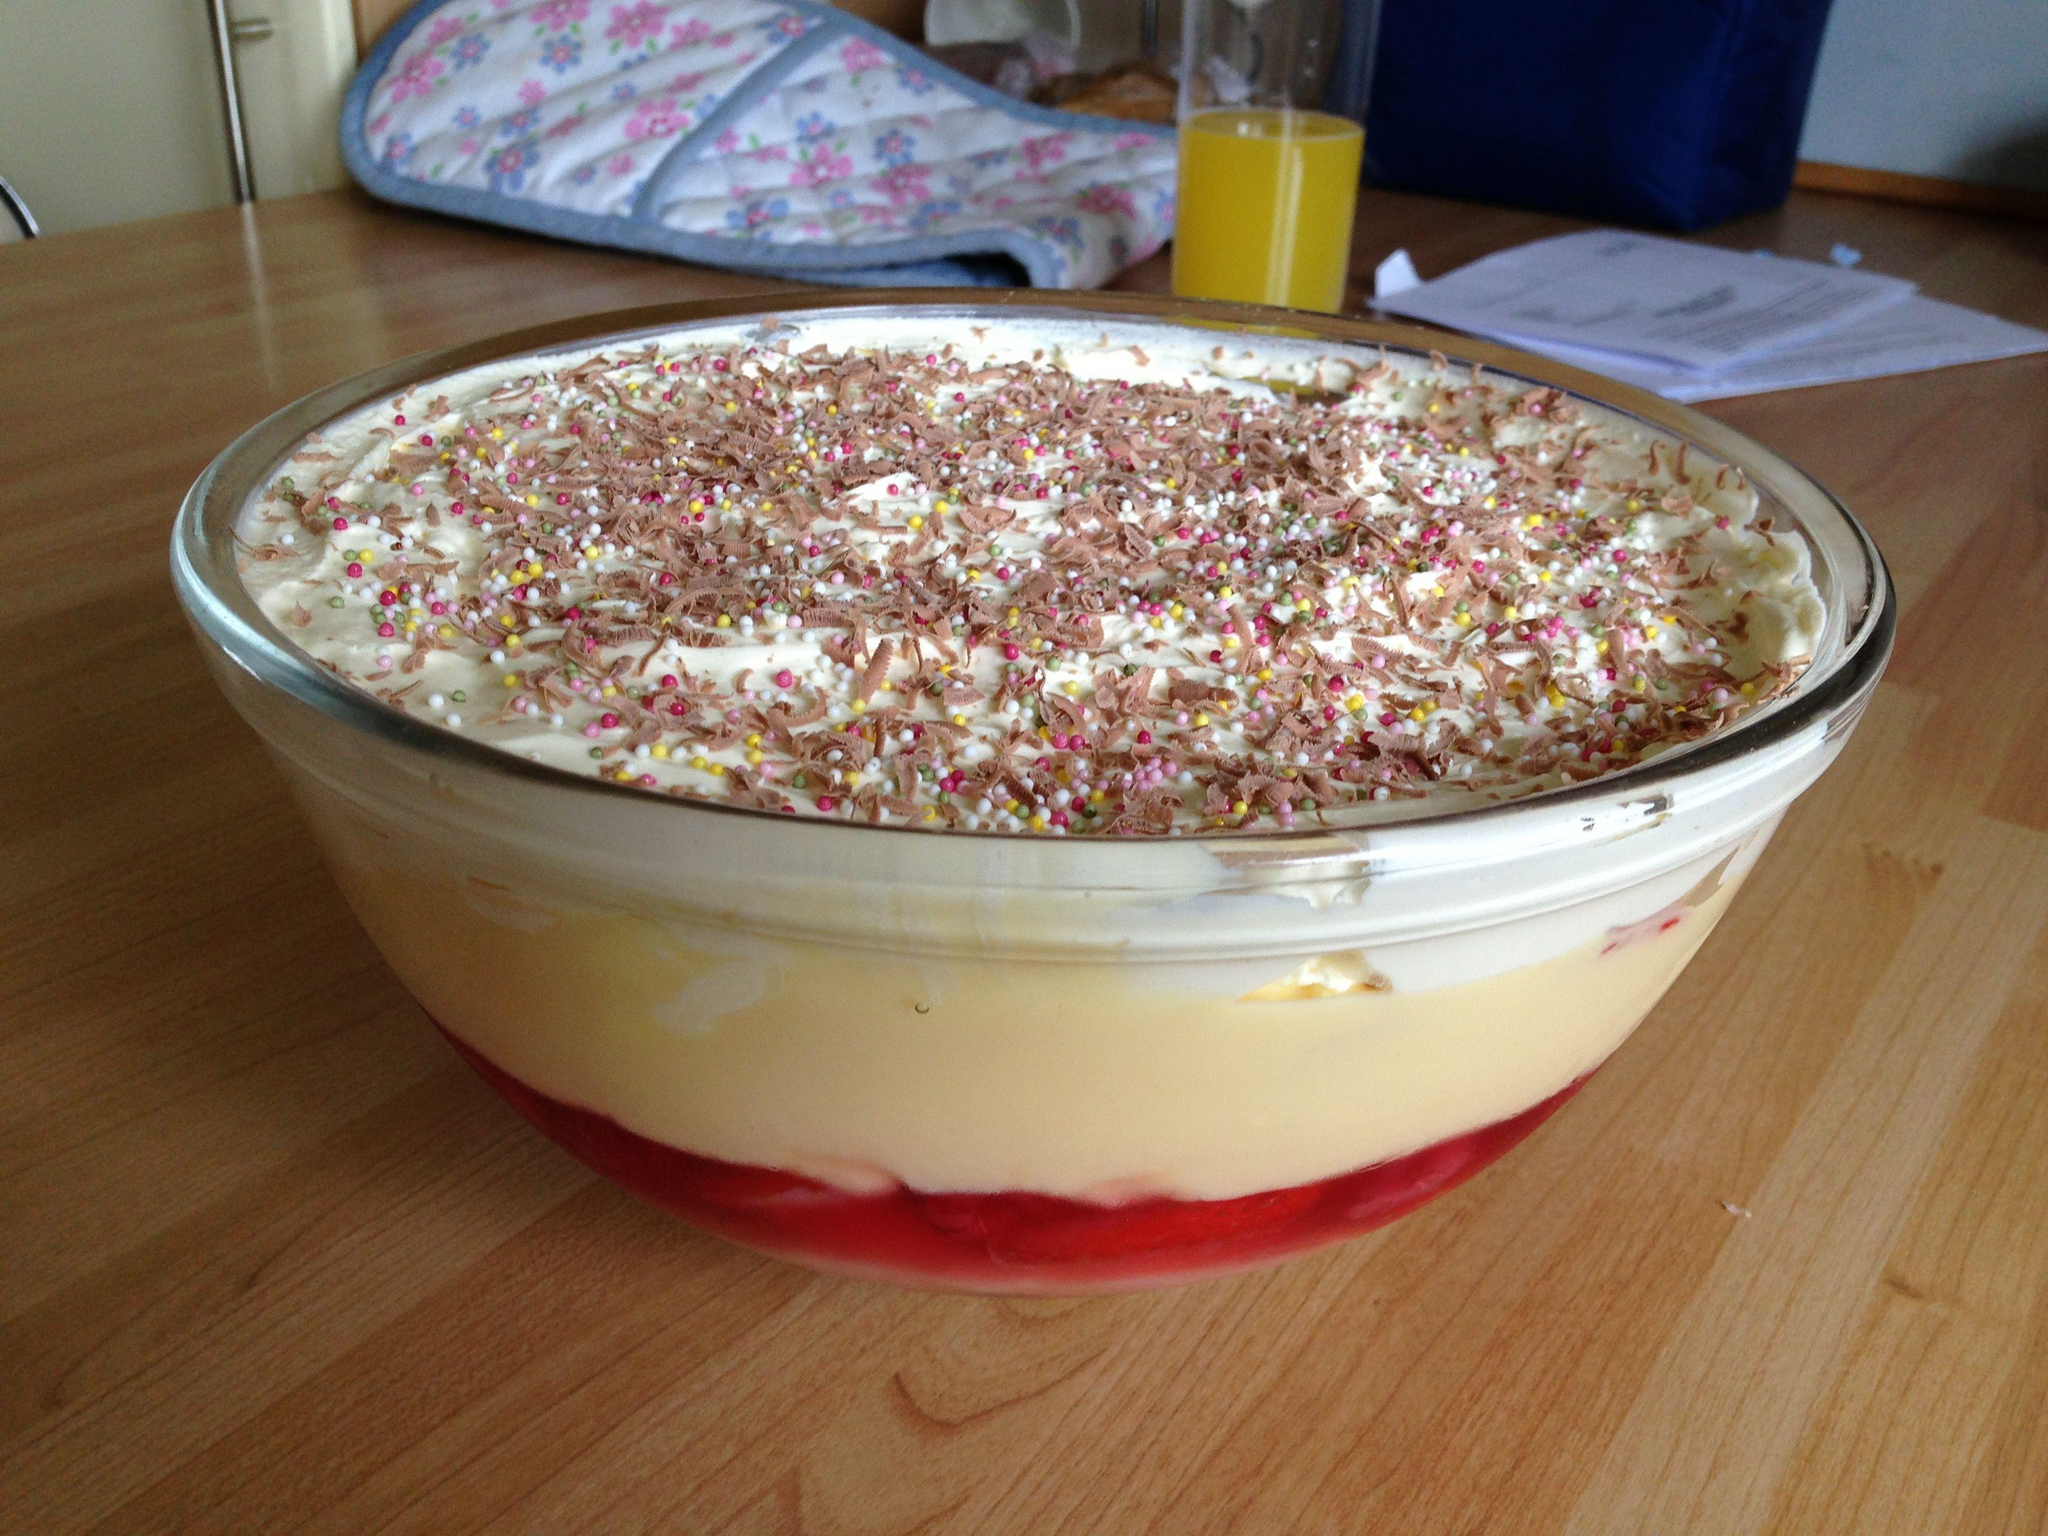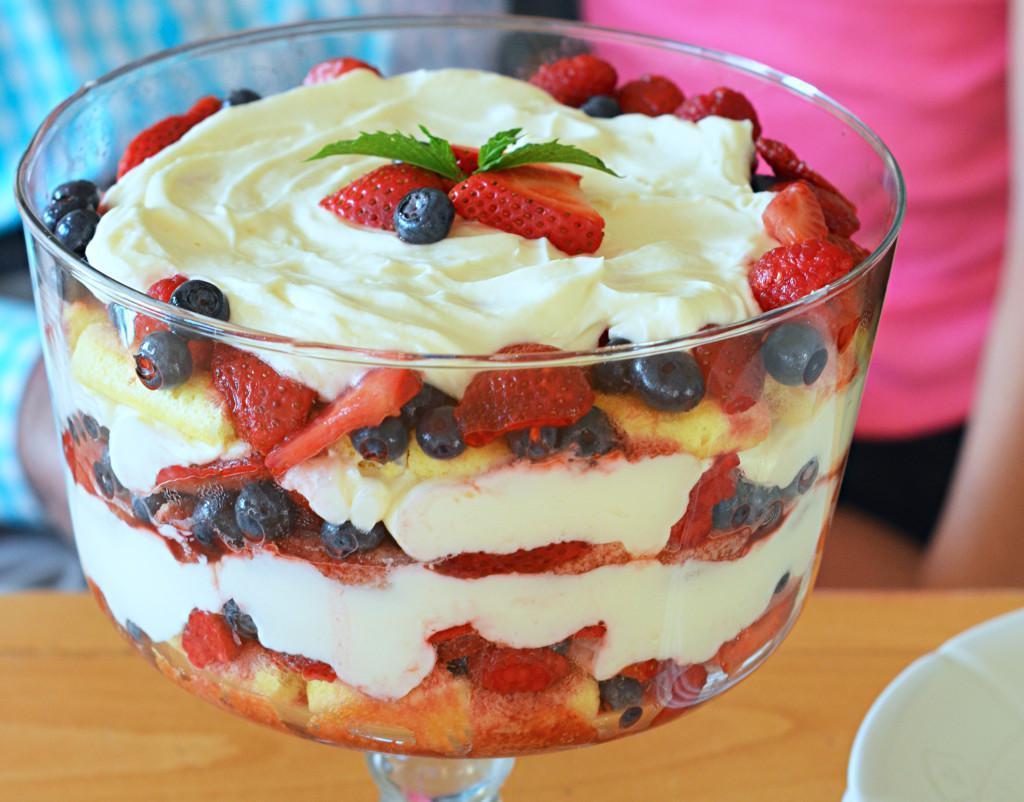The first image is the image on the left, the second image is the image on the right. Considering the images on both sides, is "An image shows a dessert with garnish that includes red berries and a green leaf." valid? Answer yes or no. Yes. 